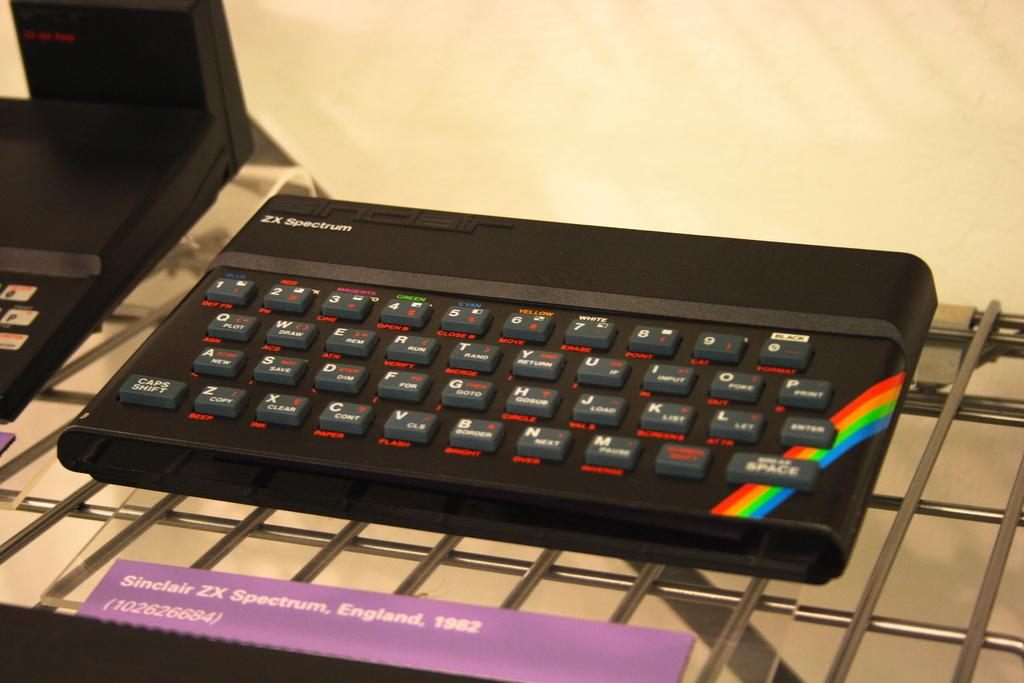<image>
Offer a succinct explanation of the picture presented. A keyboard that was created in England in 1982. 